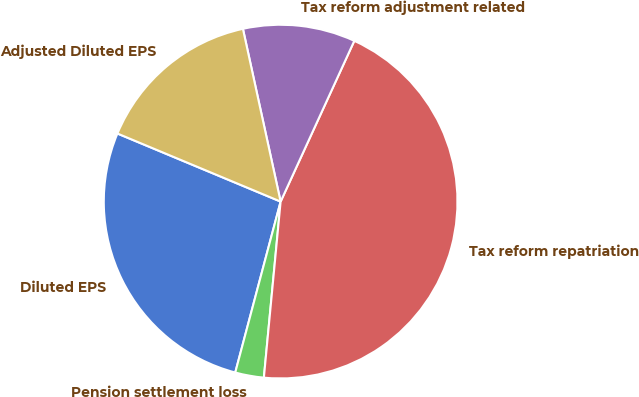<chart> <loc_0><loc_0><loc_500><loc_500><pie_chart><fcel>Diluted EPS<fcel>Pension settlement loss<fcel>Tax reform repatriation<fcel>Tax reform adjustment related<fcel>Adjusted Diluted EPS<nl><fcel>27.16%<fcel>2.62%<fcel>44.67%<fcel>10.26%<fcel>15.29%<nl></chart> 